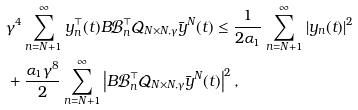<formula> <loc_0><loc_0><loc_500><loc_500>& \gamma ^ { 4 } \sum _ { n = N + 1 } ^ { \infty } y _ { n } ^ { \top } ( t ) B \mathcal { B } _ { n } ^ { \top } \mathcal { Q } _ { N \times N , \gamma } \bar { y } ^ { N } ( t ) \leq \frac { 1 } { 2 \alpha _ { 1 } } \sum _ { n = N + 1 } ^ { \infty } \left | y _ { n } ( t ) \right | ^ { 2 } \\ & + \frac { \alpha _ { 1 } \gamma ^ { 8 } } { 2 } \sum _ { n = N + 1 } ^ { \infty } \left | B \mathcal { B } _ { n } ^ { \top } \mathcal { Q } _ { N \times N , \gamma } \bar { y } ^ { N } ( t ) \right | ^ { 2 } ,</formula> 